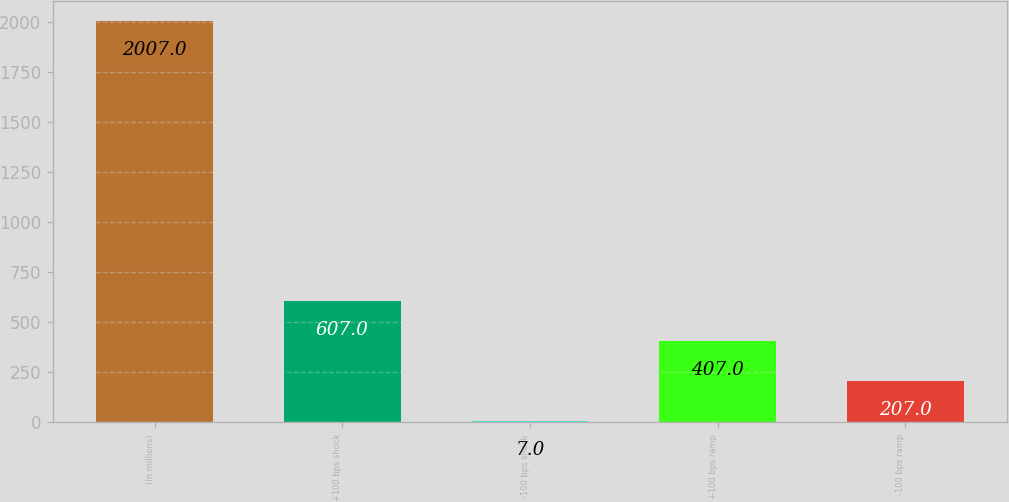Convert chart to OTSL. <chart><loc_0><loc_0><loc_500><loc_500><bar_chart><fcel>(In millions)<fcel>+100 bps shock<fcel>-100 bps shock<fcel>+100 bps ramp<fcel>-100 bps ramp<nl><fcel>2007<fcel>607<fcel>7<fcel>407<fcel>207<nl></chart> 